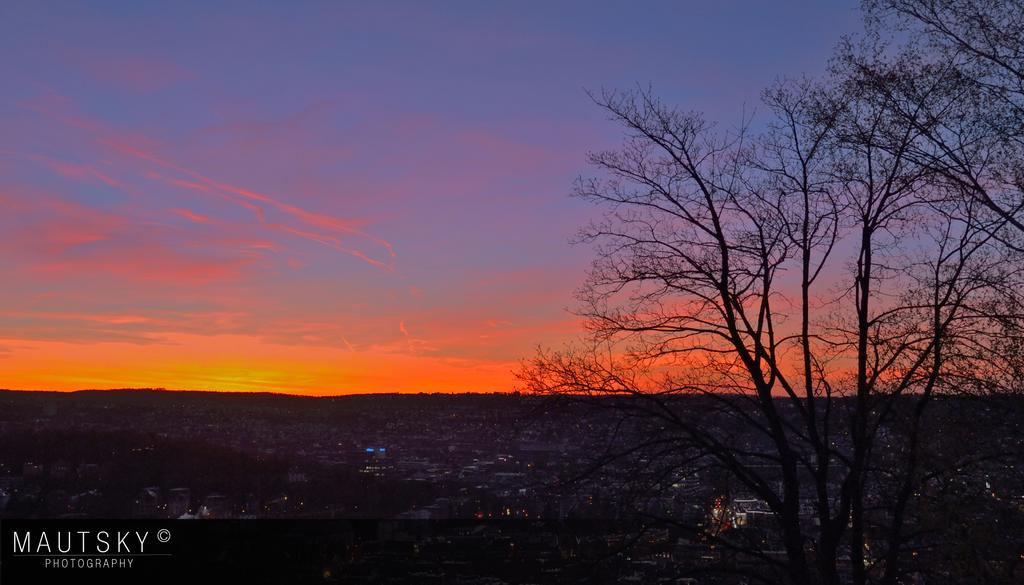Where was the picture taken? The picture was clicked outside the city. What can be seen in the right bottom of the image? There are trees in the right bottom of the image. What type of structures are visible in the background of the image? There are many buildings in the background of the image. What is visible at the top of the image? The sky is visible at the top of the image. What type of table is being used for the protest in the image? There is no protest or table present in the image. 